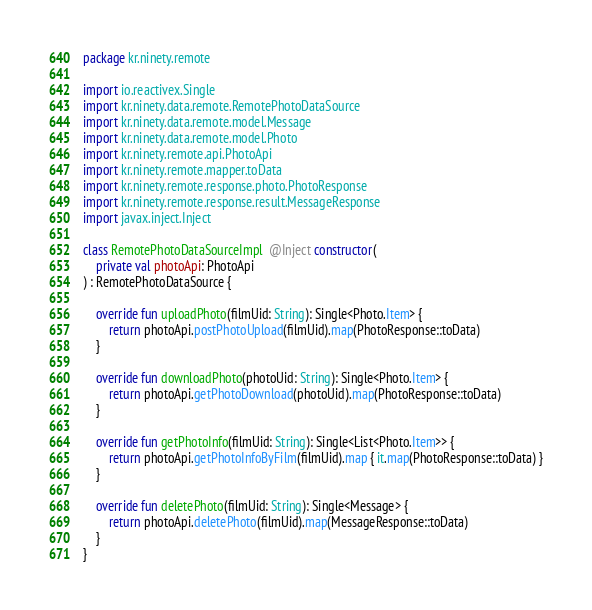Convert code to text. <code><loc_0><loc_0><loc_500><loc_500><_Kotlin_>package kr.ninety.remote

import io.reactivex.Single
import kr.ninety.data.remote.RemotePhotoDataSource
import kr.ninety.data.remote.model.Message
import kr.ninety.data.remote.model.Photo
import kr.ninety.remote.api.PhotoApi
import kr.ninety.remote.mapper.toData
import kr.ninety.remote.response.photo.PhotoResponse
import kr.ninety.remote.response.result.MessageResponse
import javax.inject.Inject

class RemotePhotoDataSourceImpl  @Inject constructor(
    private val photoApi: PhotoApi
) : RemotePhotoDataSource {

    override fun uploadPhoto(filmUid: String): Single<Photo.Item> {
        return photoApi.postPhotoUpload(filmUid).map(PhotoResponse::toData)
    }

    override fun downloadPhoto(photoUid: String): Single<Photo.Item> {
        return photoApi.getPhotoDownload(photoUid).map(PhotoResponse::toData)
    }

    override fun getPhotoInfo(filmUid: String): Single<List<Photo.Item>> {
        return photoApi.getPhotoInfoByFilm(filmUid).map { it.map(PhotoResponse::toData) }
    }

    override fun deletePhoto(filmUid: String): Single<Message> {
        return photoApi.deletePhoto(filmUid).map(MessageResponse::toData)
    }
}</code> 